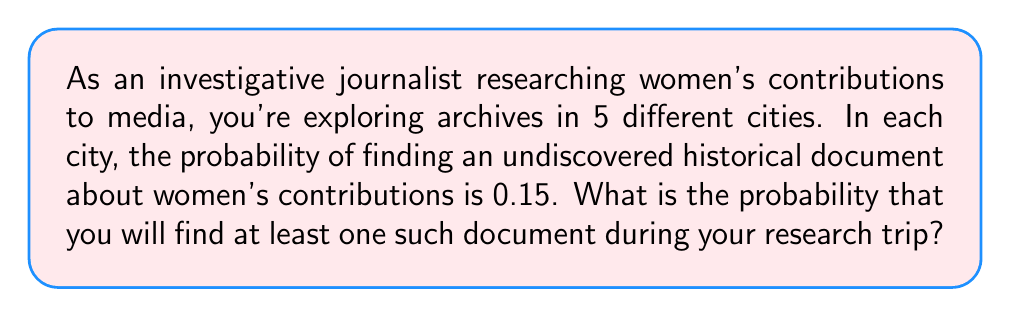Show me your answer to this math problem. To solve this problem, we can use the concept of complementary events in probability theory.

1. Let's define the event A as "finding at least one undiscovered document".
2. The complement of A is "not finding any documents".

3. The probability of not finding a document in one city is:
   $1 - 0.15 = 0.85$

4. Since the searches in each city are independent events, we can use the multiplication rule of probability. The probability of not finding any documents in all 5 cities is:
   $$(0.85)^5 = 0.4437$$

5. Therefore, the probability of finding at least one document (our desired outcome) is:
   $$P(A) = 1 - P(\text{not A}) = 1 - (0.85)^5 = 1 - 0.4437 = 0.5563$$

6. Converting to a percentage:
   $$0.5563 \times 100\% = 55.63\%$$
Answer: The probability of finding at least one undiscovered historical document about women's contributions to media during your research trip is approximately 55.63%. 